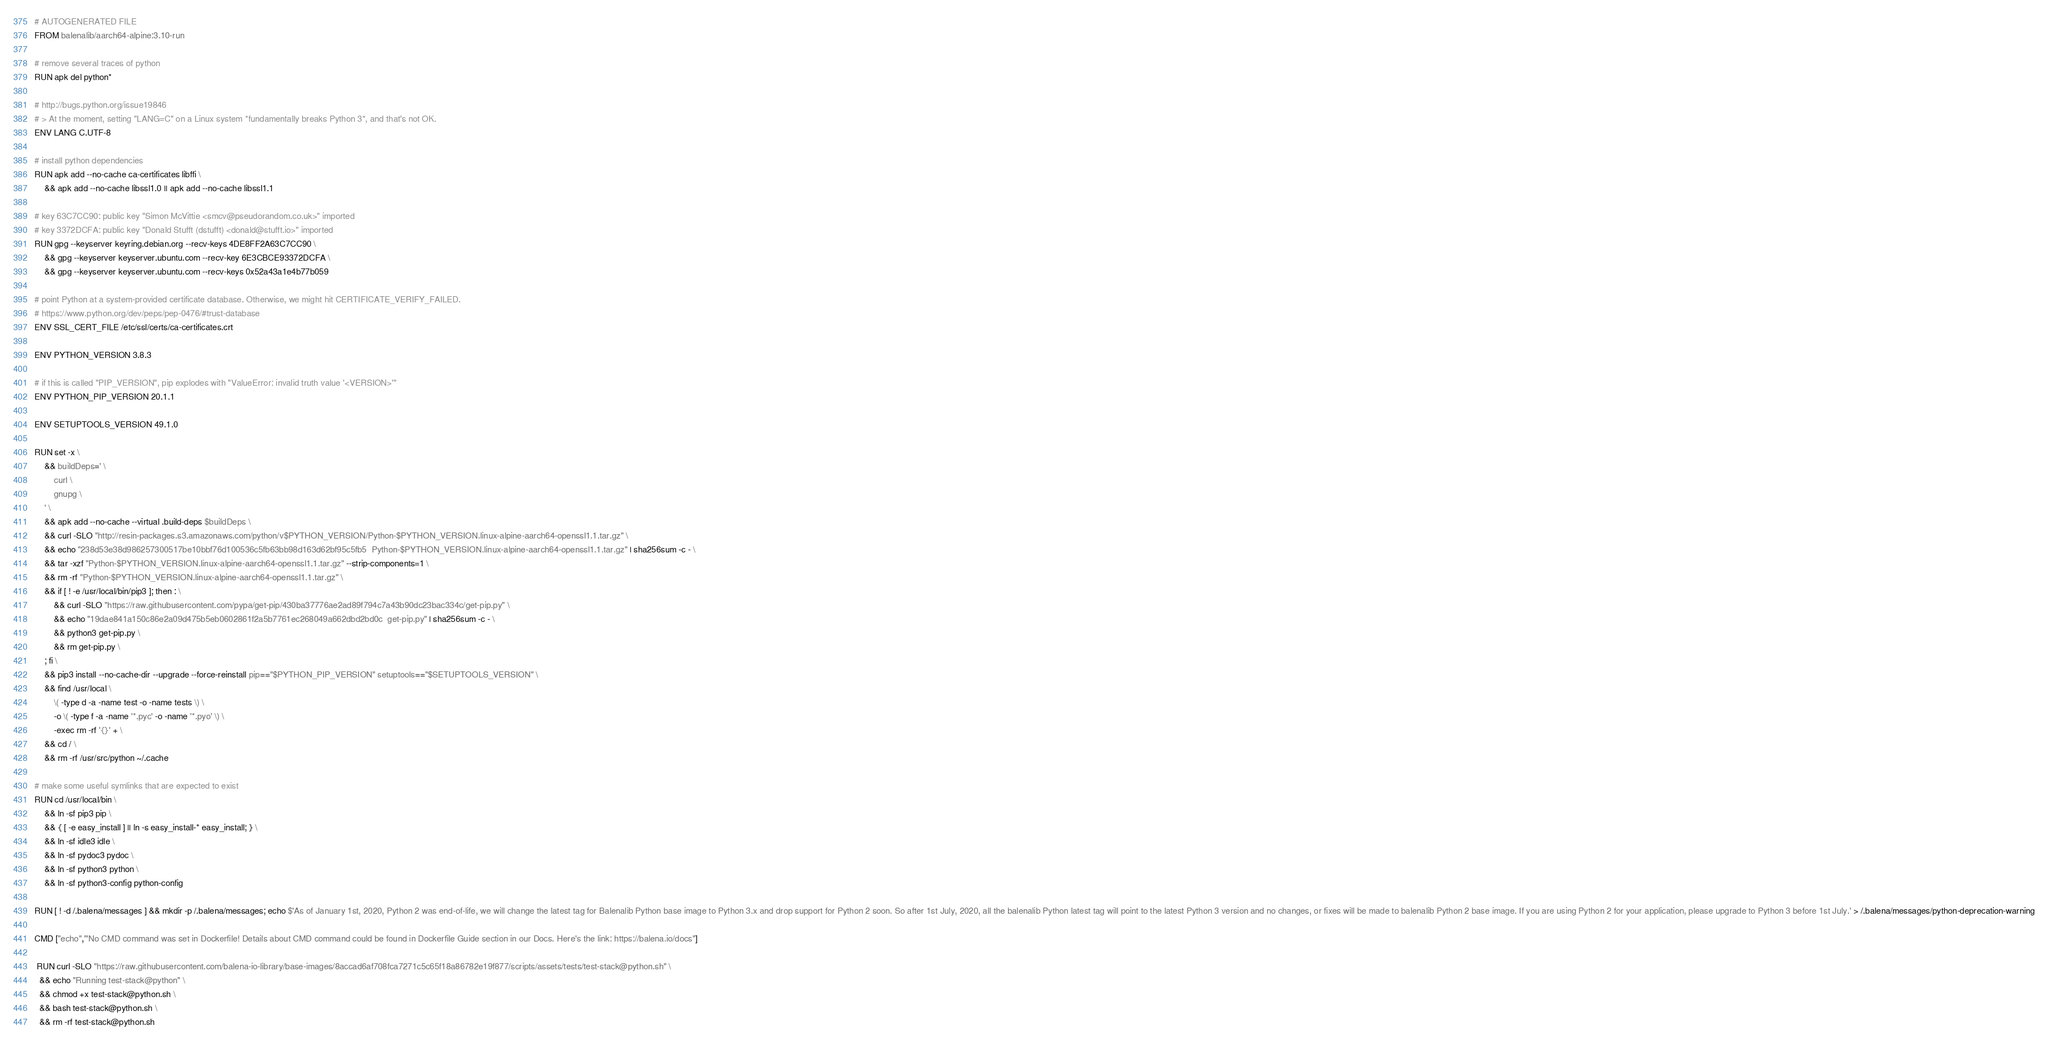Convert code to text. <code><loc_0><loc_0><loc_500><loc_500><_Dockerfile_># AUTOGENERATED FILE
FROM balenalib/aarch64-alpine:3.10-run

# remove several traces of python
RUN apk del python*

# http://bugs.python.org/issue19846
# > At the moment, setting "LANG=C" on a Linux system *fundamentally breaks Python 3*, and that's not OK.
ENV LANG C.UTF-8

# install python dependencies
RUN apk add --no-cache ca-certificates libffi \
	&& apk add --no-cache libssl1.0 || apk add --no-cache libssl1.1

# key 63C7CC90: public key "Simon McVittie <smcv@pseudorandom.co.uk>" imported
# key 3372DCFA: public key "Donald Stufft (dstufft) <donald@stufft.io>" imported
RUN gpg --keyserver keyring.debian.org --recv-keys 4DE8FF2A63C7CC90 \
	&& gpg --keyserver keyserver.ubuntu.com --recv-key 6E3CBCE93372DCFA \
	&& gpg --keyserver keyserver.ubuntu.com --recv-keys 0x52a43a1e4b77b059

# point Python at a system-provided certificate database. Otherwise, we might hit CERTIFICATE_VERIFY_FAILED.
# https://www.python.org/dev/peps/pep-0476/#trust-database
ENV SSL_CERT_FILE /etc/ssl/certs/ca-certificates.crt

ENV PYTHON_VERSION 3.8.3

# if this is called "PIP_VERSION", pip explodes with "ValueError: invalid truth value '<VERSION>'"
ENV PYTHON_PIP_VERSION 20.1.1

ENV SETUPTOOLS_VERSION 49.1.0

RUN set -x \
	&& buildDeps=' \
		curl \
		gnupg \
	' \
	&& apk add --no-cache --virtual .build-deps $buildDeps \
	&& curl -SLO "http://resin-packages.s3.amazonaws.com/python/v$PYTHON_VERSION/Python-$PYTHON_VERSION.linux-alpine-aarch64-openssl1.1.tar.gz" \
	&& echo "238d53e38d986257300517be10bbf76d100536c5fb63bb98d163d62bf95c5fb5  Python-$PYTHON_VERSION.linux-alpine-aarch64-openssl1.1.tar.gz" | sha256sum -c - \
	&& tar -xzf "Python-$PYTHON_VERSION.linux-alpine-aarch64-openssl1.1.tar.gz" --strip-components=1 \
	&& rm -rf "Python-$PYTHON_VERSION.linux-alpine-aarch64-openssl1.1.tar.gz" \
	&& if [ ! -e /usr/local/bin/pip3 ]; then : \
		&& curl -SLO "https://raw.githubusercontent.com/pypa/get-pip/430ba37776ae2ad89f794c7a43b90dc23bac334c/get-pip.py" \
		&& echo "19dae841a150c86e2a09d475b5eb0602861f2a5b7761ec268049a662dbd2bd0c  get-pip.py" | sha256sum -c - \
		&& python3 get-pip.py \
		&& rm get-pip.py \
	; fi \
	&& pip3 install --no-cache-dir --upgrade --force-reinstall pip=="$PYTHON_PIP_VERSION" setuptools=="$SETUPTOOLS_VERSION" \
	&& find /usr/local \
		\( -type d -a -name test -o -name tests \) \
		-o \( -type f -a -name '*.pyc' -o -name '*.pyo' \) \
		-exec rm -rf '{}' + \
	&& cd / \
	&& rm -rf /usr/src/python ~/.cache

# make some useful symlinks that are expected to exist
RUN cd /usr/local/bin \
	&& ln -sf pip3 pip \
	&& { [ -e easy_install ] || ln -s easy_install-* easy_install; } \
	&& ln -sf idle3 idle \
	&& ln -sf pydoc3 pydoc \
	&& ln -sf python3 python \
	&& ln -sf python3-config python-config

RUN [ ! -d /.balena/messages ] && mkdir -p /.balena/messages; echo $'As of January 1st, 2020, Python 2 was end-of-life, we will change the latest tag for Balenalib Python base image to Python 3.x and drop support for Python 2 soon. So after 1st July, 2020, all the balenalib Python latest tag will point to the latest Python 3 version and no changes, or fixes will be made to balenalib Python 2 base image. If you are using Python 2 for your application, please upgrade to Python 3 before 1st July.' > /.balena/messages/python-deprecation-warning

CMD ["echo","'No CMD command was set in Dockerfile! Details about CMD command could be found in Dockerfile Guide section in our Docs. Here's the link: https://balena.io/docs"]

 RUN curl -SLO "https://raw.githubusercontent.com/balena-io-library/base-images/8accad6af708fca7271c5c65f18a86782e19f877/scripts/assets/tests/test-stack@python.sh" \
  && echo "Running test-stack@python" \
  && chmod +x test-stack@python.sh \
  && bash test-stack@python.sh \
  && rm -rf test-stack@python.sh 
</code> 